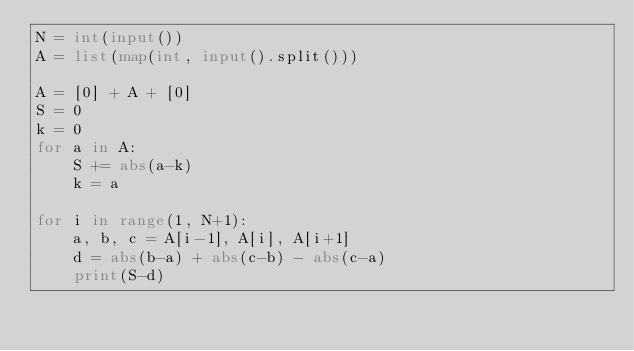Convert code to text. <code><loc_0><loc_0><loc_500><loc_500><_Python_>N = int(input())
A = list(map(int, input().split()))

A = [0] + A + [0]
S = 0
k = 0
for a in A:
    S += abs(a-k)
    k = a

for i in range(1, N+1):
    a, b, c = A[i-1], A[i], A[i+1]
    d = abs(b-a) + abs(c-b) - abs(c-a)
    print(S-d)
</code> 